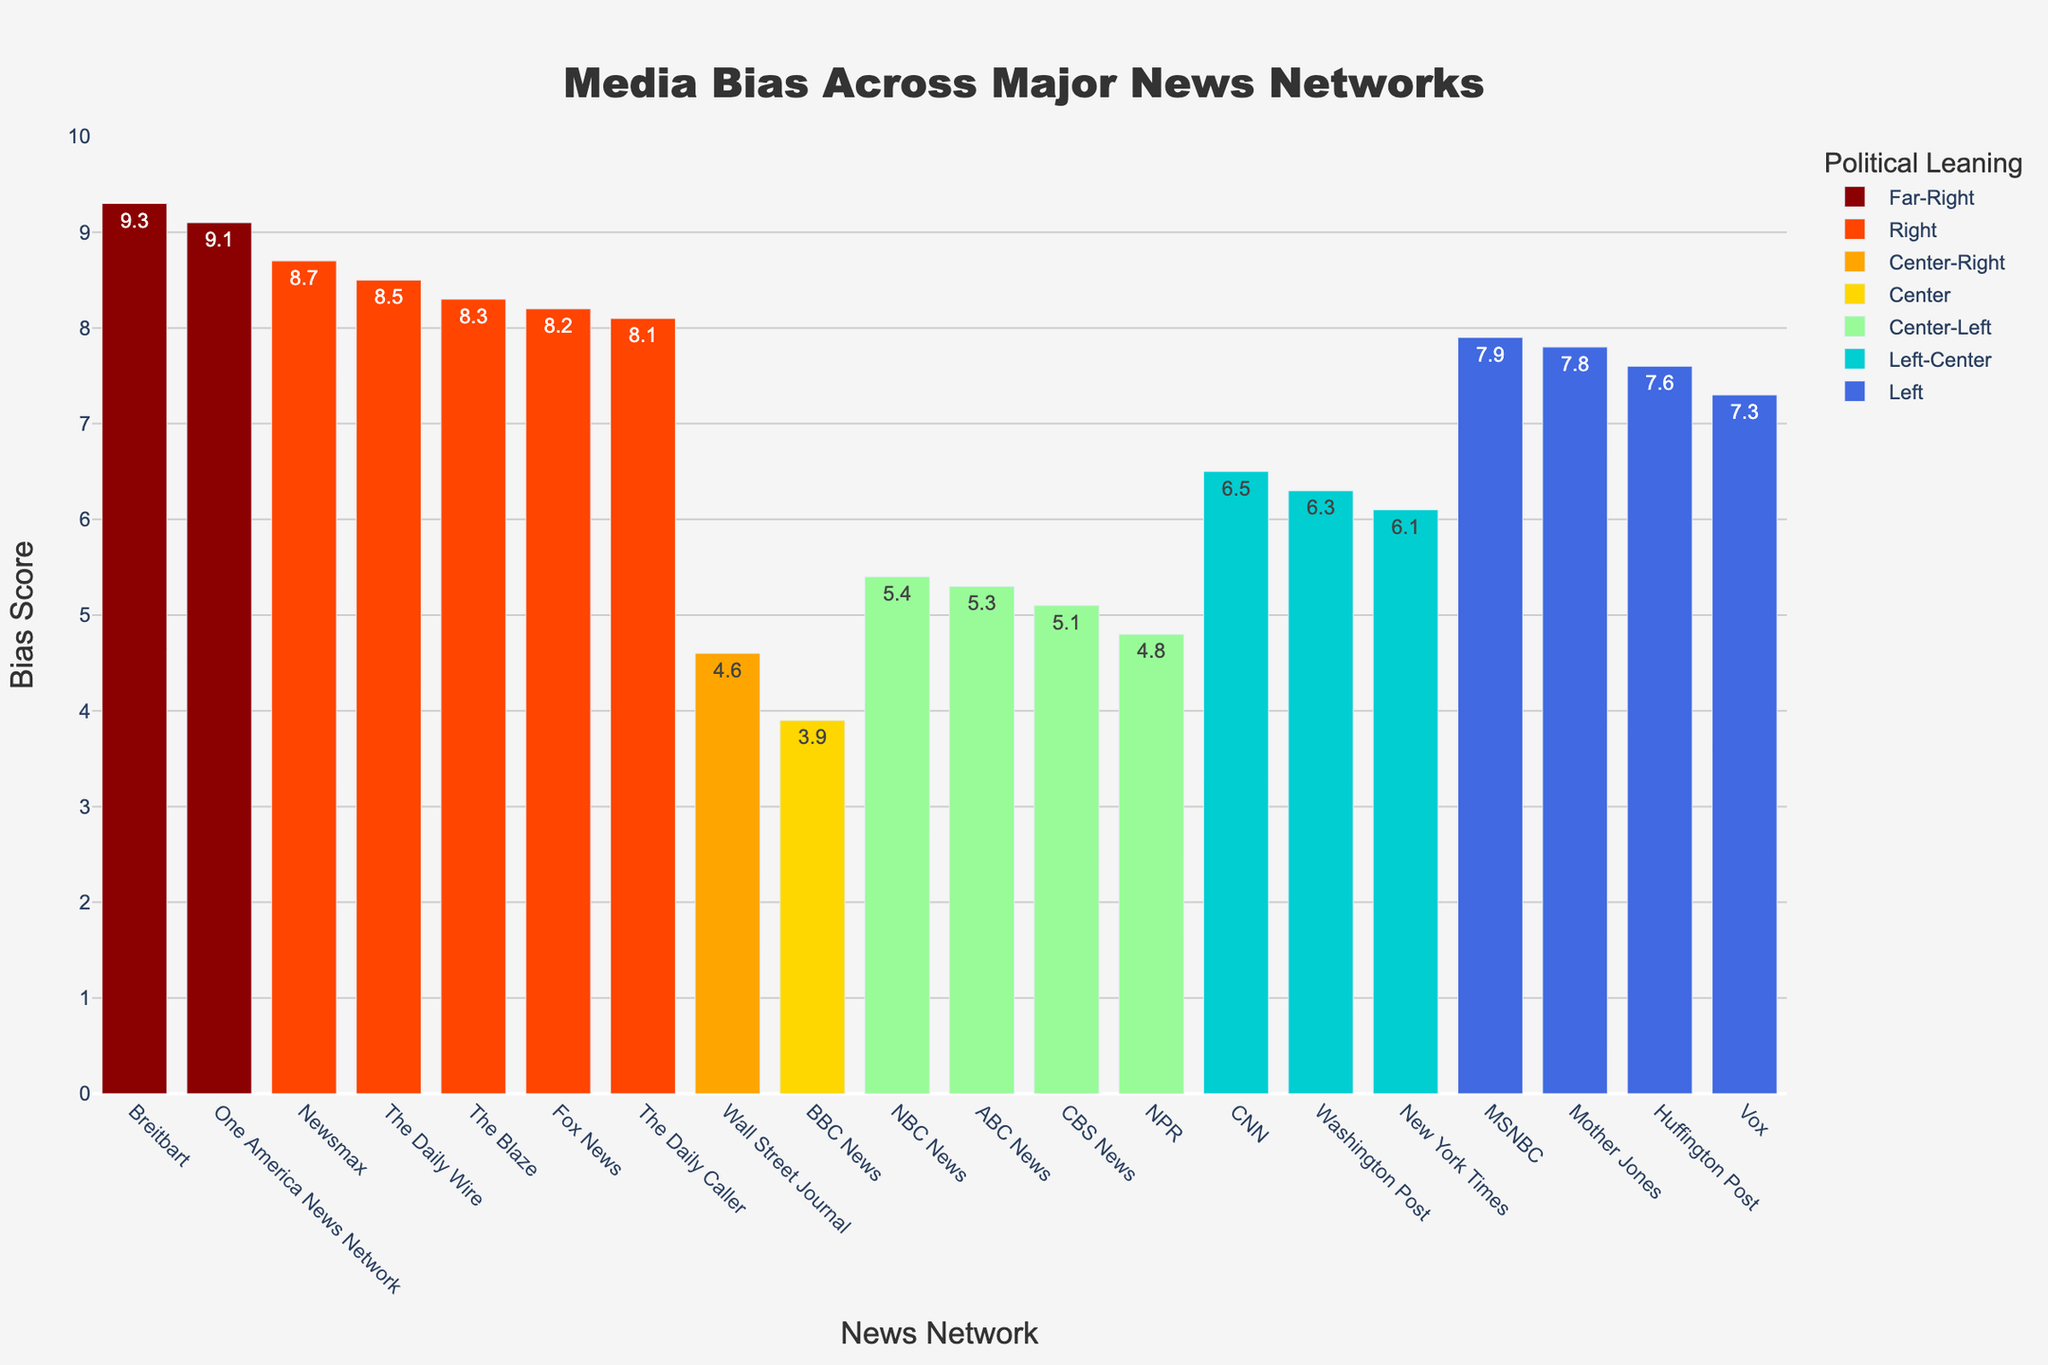Which news network has the highest bias score? Looking at the chart, we can identify the news network with the tallest bar, which represents the highest bias score.
Answer: Breitbart Which political leaning has the most representation in the bias scores above 8.0? To answer this, we count the number of news networks within each political leaning category that have a bias score above 8.0 by examining the chart.
Answer: Right What is the difference in bias score between BBC News and Fox News? Locate the bars representing BBC News and Fox News, then subtract the bias score of BBC News from the bias score of Fox News. Fox News has a bias score of 8.2, and BBC News has a bias score of 3.9. Thus, the difference is 8.2 - 3.9.
Answer: 4.3 Which has a higher bias score: CNN or Wall Street Journal? By comparing the height of the bars for CNN and Wall Street Journal, we can determine that CNN's bias score (6.5) is greater than the Wall Street Journal's (4.6).
Answer: CNN What is the average bias score of the 'Center-Left' networks? To find the average, sum the bias scores of all 'Center-Left' networks (ABC News: 5.3, CBS News: 5.1, NBC News: 5.4, NPR: 4.8) and then divide by the number of networks. The sum is 5.3 + 5.1 + 5.4 + 4.8 = 20.6. Dividing by the number of networks (4), the average is 20.6 / 4.
Answer: 5.15 Which network among 'Left' political leaning has the least bias score? By reviewing the bars under the 'Left' political leaning, the one with the shortest height indicates the network with the least bias score. Huffington Post, with a bias score of 7.6, has the lowest score among 'Left' networks.
Answer: Huffington Post How many networks have a bias score less than 5? Count the bars whose heights correspond to bias scores less than 5. These are BBC News (3.9) and NPR (4.8).
Answer: 2 What is the combined bias score of 'Far-Right' news networks? Sum the bias scores of all 'Far-Right' networks (One America News Network: 9.1, Breitbart: 9.3) to get the combined score. 9.1 + 9.3 = 18.4
Answer: 18.4 Which news network is the most centrist according to the bias score? By identifying the network with the bias score closest to the midpoint of the y-axis (which signifies neutrality or minimal bias), we find that BBC News, with a bias score of 3.9, is the most centrist.
Answer: BBC News 